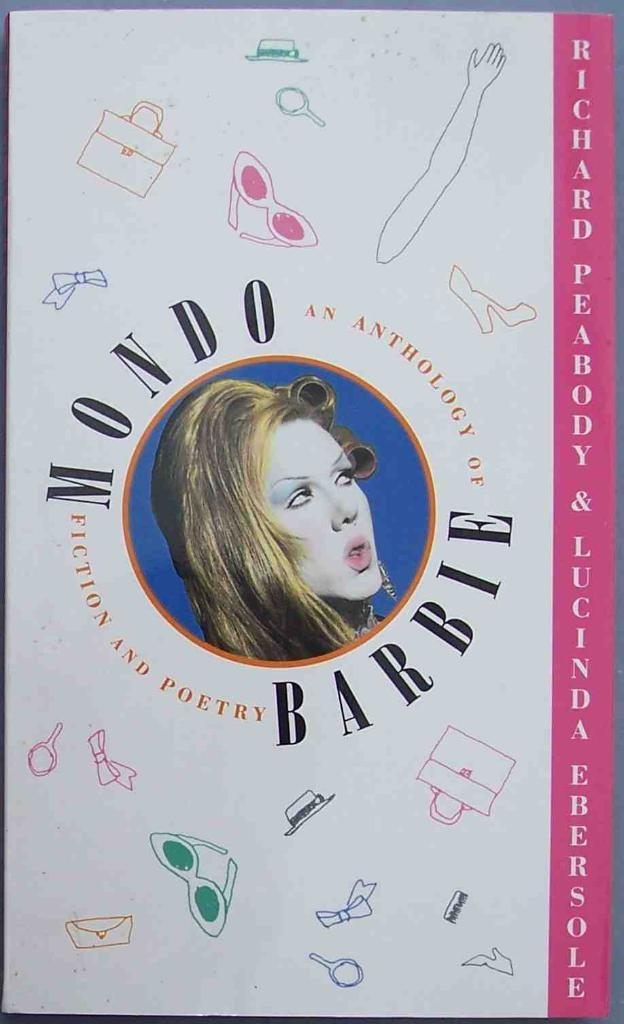What is the main subject of the image? There is a white object in the image. What can be seen on the white object? A woman's face is depicted on the object. Are there any words or letters on the object? Yes, there is text written on the object. Can you hear any music coming from the can in the image? There is no can present in the image, and therefore no music can be heard. 